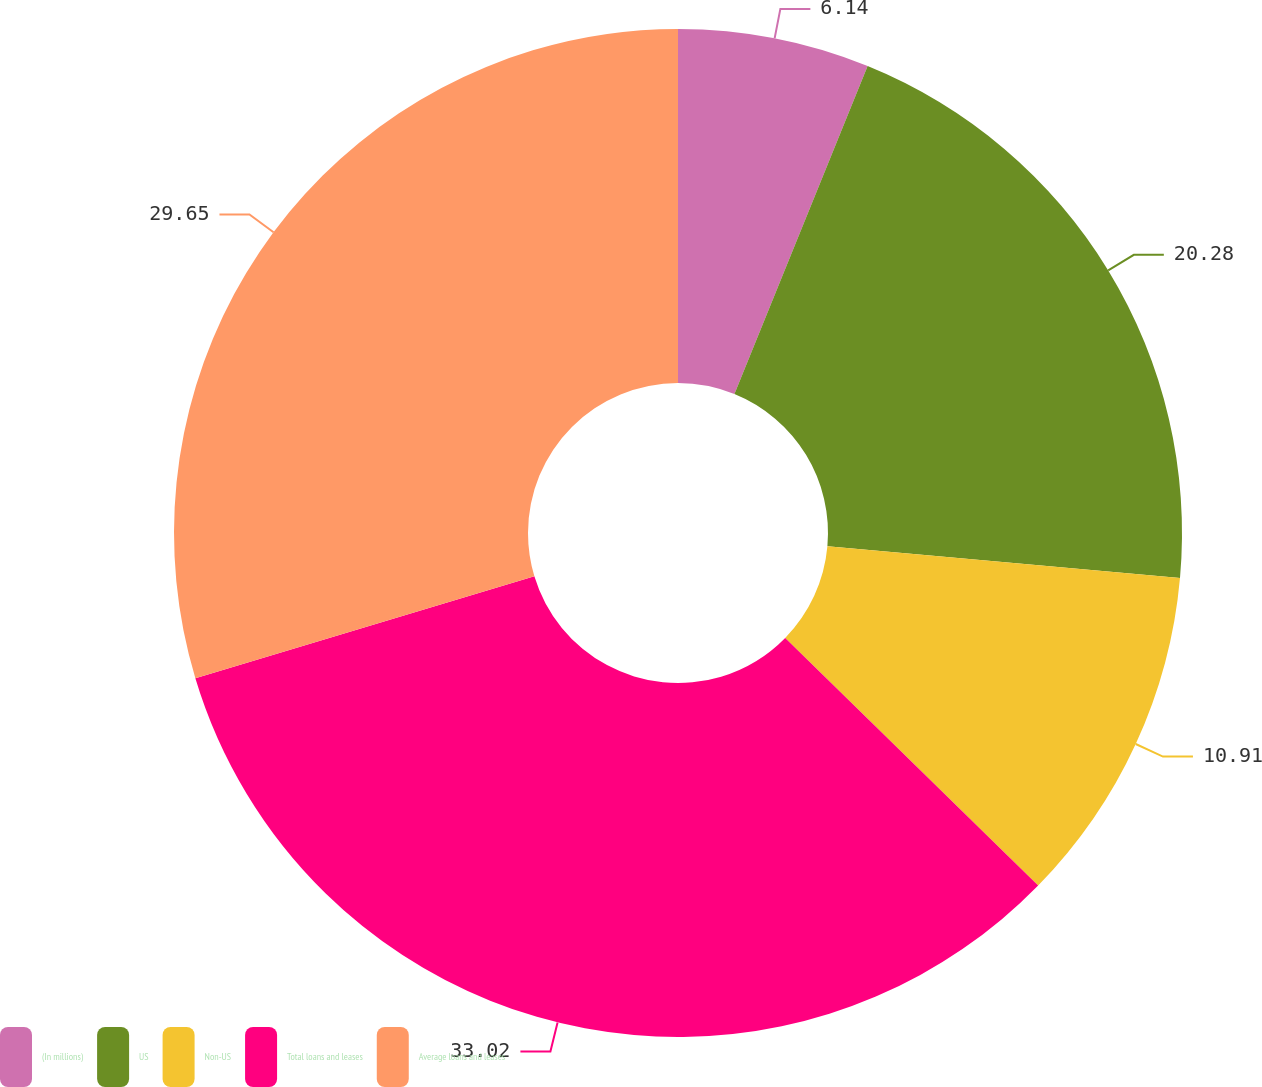Convert chart. <chart><loc_0><loc_0><loc_500><loc_500><pie_chart><fcel>(In millions)<fcel>US<fcel>Non-US<fcel>Total loans and leases<fcel>Average loans and leases<nl><fcel>6.14%<fcel>20.28%<fcel>10.91%<fcel>33.02%<fcel>29.65%<nl></chart> 